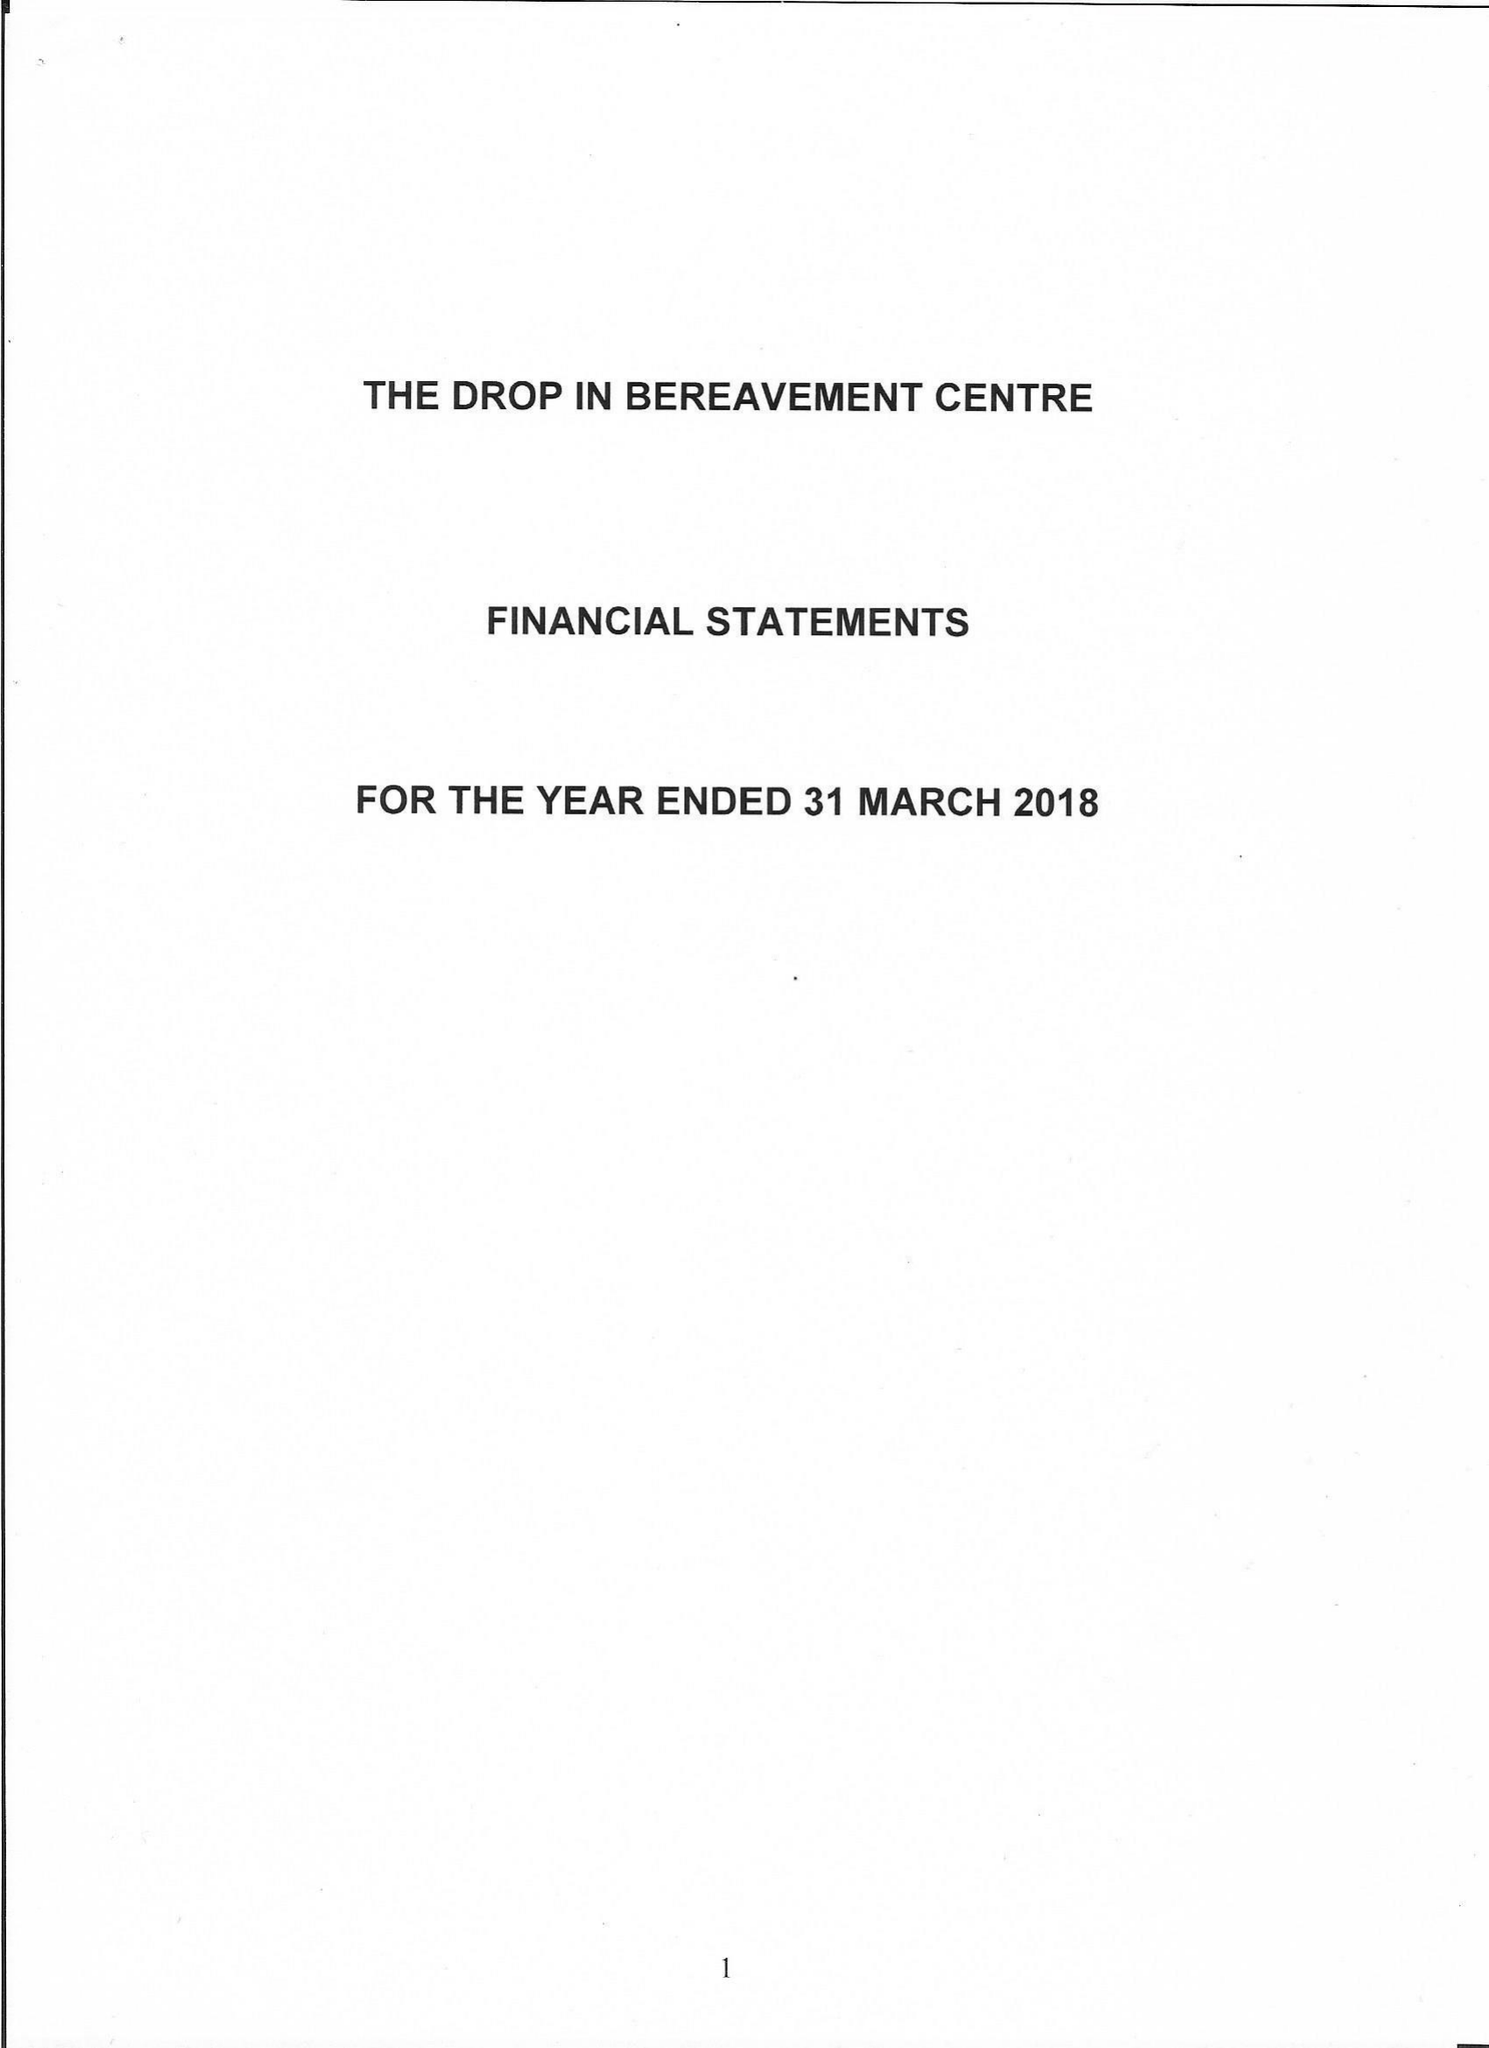What is the value for the address__post_town?
Answer the question using a single word or phrase. LONDON 